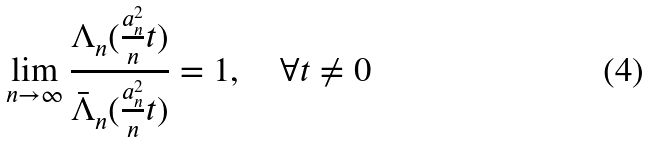Convert formula to latex. <formula><loc_0><loc_0><loc_500><loc_500>\lim _ { n \rightarrow \infty } \frac { \Lambda _ { n } ( \frac { a _ { n } ^ { 2 } } { n } t ) } { \bar { \Lambda } _ { n } ( \frac { a _ { n } ^ { 2 } } { n } t ) } = 1 , \quad \forall t \neq 0</formula> 